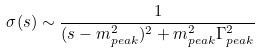Convert formula to latex. <formula><loc_0><loc_0><loc_500><loc_500>\sigma ( s ) \sim \frac { 1 } { ( s - m _ { p e a k } ^ { 2 } ) ^ { 2 } + m ^ { 2 } _ { p e a k } \Gamma ^ { 2 } _ { p e a k } }</formula> 